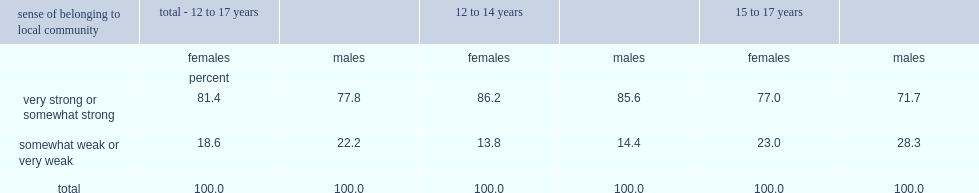What percentage of girls aged 12 to 17 reported having a "somewhat strong" or "very strong" sense of belonging to their local community? 81.4. What percentage of boys aged 12 to 17 reported having a "somewhat strong" or "very strong" sense of belonging to their local community? 77.8. What percentage of girls aged 12 to 14 reported having a "somewhat strong" or "very strong" sense of belonging to their local community? 86.2. What percentage of boys aged 12 to 14 reported having a "somewhat strong" or "very strong" sense of belonging to their local community? 85.6. What percentage of boys aged 15 to 17 reported having a strong sense of belonging to their local community? 71.7. What percentage of girls aged 15 to 17 reported having a strong sense of belonging to their local community? 77.0. 